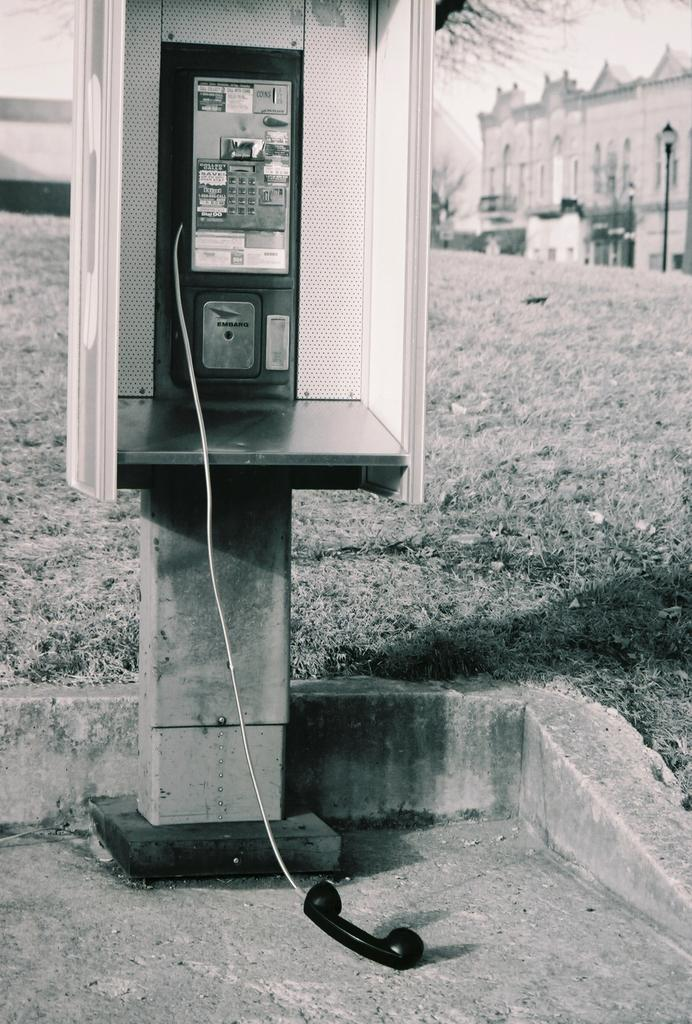What is the color scheme of the image? The image is black and white. What object can be seen in the image? There is a telephone in the image. What can be seen in the background of the image? There is a building in the distance. What other object is present in the image? There is a light pole in the image. What type of produce is being harvested in the image? There is no produce present in the image; it features a telephone, a building in the distance, and a light pole. What emotion is being expressed by the person using the telephone in the image? The image does not show any people, so it is impossible to determine any emotions being expressed. 